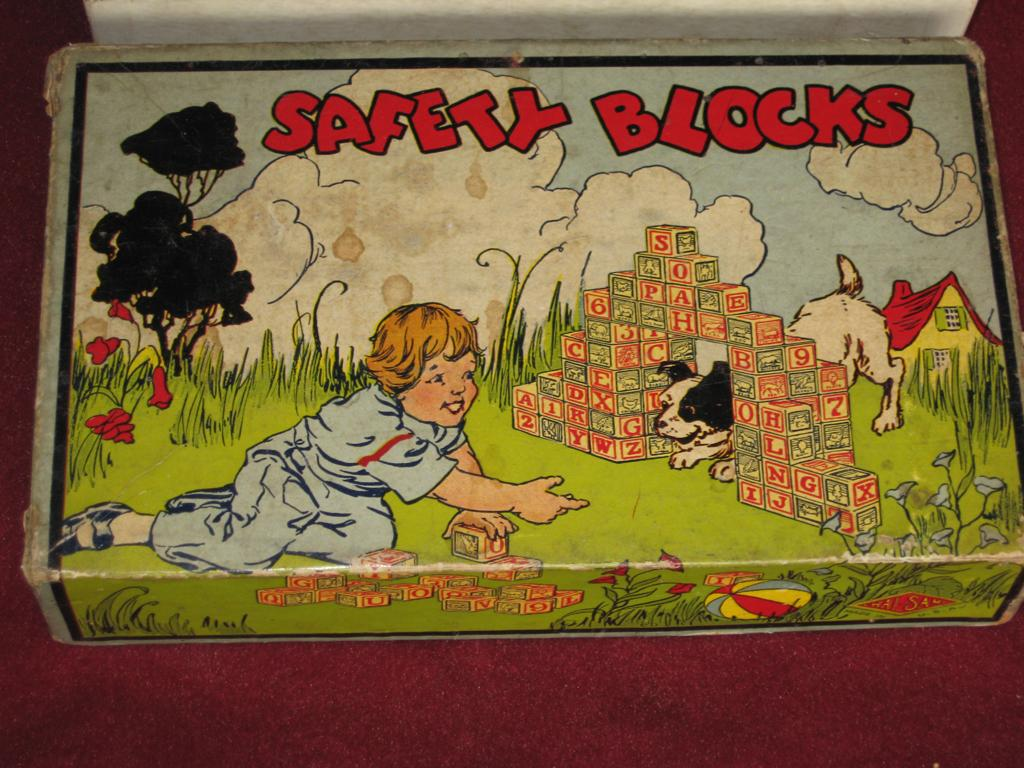What is the main object in the image? There is a box in the image. What is depicted on the box? The box has a print of a baby playing on grassland with a puppy. What can be seen behind the box? There is a house behind the box. What is visible above the box? The sky with clouds is visible above the box. On what is the box placed? The box is on a table. Can you tell me how many women are present in the image? There are no women present in the image; it features a box with a print of a baby and a puppy. What type of rat can be seen interacting with the baby in the image? There is no rat present in the image; it only features a baby and a puppy playing on grassland. 